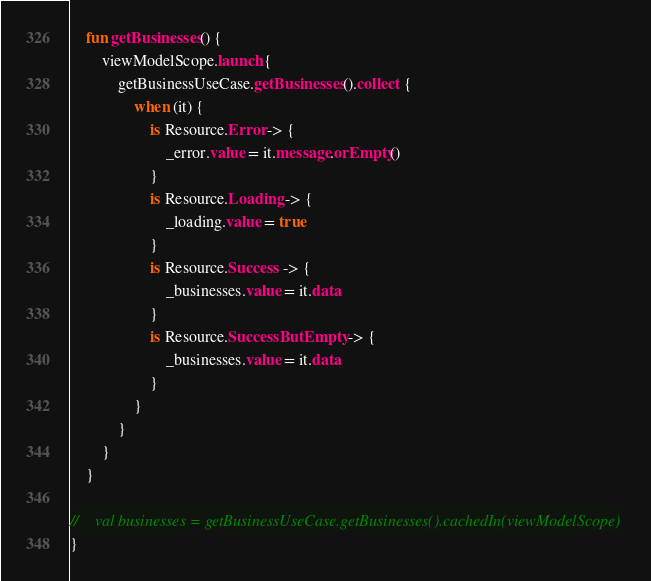Convert code to text. <code><loc_0><loc_0><loc_500><loc_500><_Kotlin_>
    fun getBusinesses() {
        viewModelScope.launch {
            getBusinessUseCase.getBusinesses().collect {
                when (it) {
                    is Resource.Error -> {
                        _error.value = it.message.orEmpty()
                    }
                    is Resource.Loading -> {
                        _loading.value = true
                    }
                    is Resource.Success -> {
                        _businesses.value = it.data
                    }
                    is Resource.SuccessButEmpty -> {
                        _businesses.value = it.data
                    }
                }
            }
        }
    }

//    val businesses = getBusinessUseCase.getBusinesses().cachedIn(viewModelScope)
}
</code> 